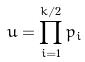Convert formula to latex. <formula><loc_0><loc_0><loc_500><loc_500>u = \prod _ { i = 1 } ^ { k / 2 } p _ { i }</formula> 